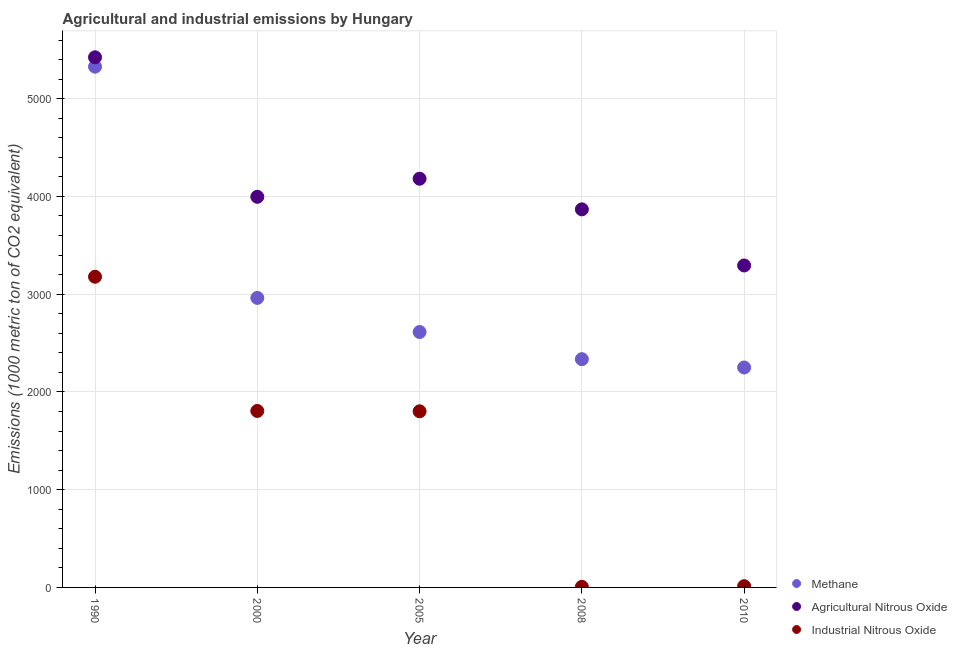How many different coloured dotlines are there?
Give a very brief answer. 3. Is the number of dotlines equal to the number of legend labels?
Offer a terse response. Yes. What is the amount of industrial nitrous oxide emissions in 2010?
Make the answer very short. 12.5. Across all years, what is the maximum amount of methane emissions?
Provide a short and direct response. 5327.6. Across all years, what is the minimum amount of methane emissions?
Your answer should be compact. 2250. In which year was the amount of methane emissions maximum?
Provide a short and direct response. 1990. What is the total amount of agricultural nitrous oxide emissions in the graph?
Keep it short and to the point. 2.08e+04. What is the difference between the amount of methane emissions in 2008 and that in 2010?
Make the answer very short. 85.2. What is the difference between the amount of industrial nitrous oxide emissions in 2010 and the amount of methane emissions in 2008?
Offer a very short reply. -2322.7. What is the average amount of agricultural nitrous oxide emissions per year?
Your response must be concise. 4152.54. In the year 1990, what is the difference between the amount of agricultural nitrous oxide emissions and amount of methane emissions?
Your answer should be compact. 95.9. What is the ratio of the amount of agricultural nitrous oxide emissions in 2000 to that in 2010?
Your answer should be compact. 1.21. What is the difference between the highest and the second highest amount of industrial nitrous oxide emissions?
Give a very brief answer. 1373.2. What is the difference between the highest and the lowest amount of industrial nitrous oxide emissions?
Provide a short and direct response. 3172.6. In how many years, is the amount of industrial nitrous oxide emissions greater than the average amount of industrial nitrous oxide emissions taken over all years?
Make the answer very short. 3. Is it the case that in every year, the sum of the amount of methane emissions and amount of agricultural nitrous oxide emissions is greater than the amount of industrial nitrous oxide emissions?
Your answer should be compact. Yes. What is the difference between two consecutive major ticks on the Y-axis?
Make the answer very short. 1000. Does the graph contain any zero values?
Keep it short and to the point. No. Where does the legend appear in the graph?
Give a very brief answer. Bottom right. How many legend labels are there?
Offer a very short reply. 3. How are the legend labels stacked?
Ensure brevity in your answer.  Vertical. What is the title of the graph?
Provide a short and direct response. Agricultural and industrial emissions by Hungary. Does "Agricultural Nitrous Oxide" appear as one of the legend labels in the graph?
Your answer should be very brief. Yes. What is the label or title of the X-axis?
Your answer should be compact. Year. What is the label or title of the Y-axis?
Your answer should be very brief. Emissions (1000 metric ton of CO2 equivalent). What is the Emissions (1000 metric ton of CO2 equivalent) in Methane in 1990?
Your answer should be very brief. 5327.6. What is the Emissions (1000 metric ton of CO2 equivalent) of Agricultural Nitrous Oxide in 1990?
Your response must be concise. 5423.5. What is the Emissions (1000 metric ton of CO2 equivalent) of Industrial Nitrous Oxide in 1990?
Offer a terse response. 3178.6. What is the Emissions (1000 metric ton of CO2 equivalent) in Methane in 2000?
Provide a short and direct response. 2961.9. What is the Emissions (1000 metric ton of CO2 equivalent) of Agricultural Nitrous Oxide in 2000?
Your response must be concise. 3996.3. What is the Emissions (1000 metric ton of CO2 equivalent) in Industrial Nitrous Oxide in 2000?
Provide a succinct answer. 1805.4. What is the Emissions (1000 metric ton of CO2 equivalent) in Methane in 2005?
Your response must be concise. 2613. What is the Emissions (1000 metric ton of CO2 equivalent) in Agricultural Nitrous Oxide in 2005?
Make the answer very short. 4181.2. What is the Emissions (1000 metric ton of CO2 equivalent) in Industrial Nitrous Oxide in 2005?
Provide a short and direct response. 1802. What is the Emissions (1000 metric ton of CO2 equivalent) in Methane in 2008?
Provide a succinct answer. 2335.2. What is the Emissions (1000 metric ton of CO2 equivalent) of Agricultural Nitrous Oxide in 2008?
Provide a short and direct response. 3868. What is the Emissions (1000 metric ton of CO2 equivalent) of Methane in 2010?
Provide a succinct answer. 2250. What is the Emissions (1000 metric ton of CO2 equivalent) of Agricultural Nitrous Oxide in 2010?
Provide a short and direct response. 3293.7. Across all years, what is the maximum Emissions (1000 metric ton of CO2 equivalent) in Methane?
Make the answer very short. 5327.6. Across all years, what is the maximum Emissions (1000 metric ton of CO2 equivalent) of Agricultural Nitrous Oxide?
Provide a short and direct response. 5423.5. Across all years, what is the maximum Emissions (1000 metric ton of CO2 equivalent) in Industrial Nitrous Oxide?
Provide a short and direct response. 3178.6. Across all years, what is the minimum Emissions (1000 metric ton of CO2 equivalent) of Methane?
Your answer should be very brief. 2250. Across all years, what is the minimum Emissions (1000 metric ton of CO2 equivalent) of Agricultural Nitrous Oxide?
Ensure brevity in your answer.  3293.7. What is the total Emissions (1000 metric ton of CO2 equivalent) in Methane in the graph?
Ensure brevity in your answer.  1.55e+04. What is the total Emissions (1000 metric ton of CO2 equivalent) in Agricultural Nitrous Oxide in the graph?
Provide a short and direct response. 2.08e+04. What is the total Emissions (1000 metric ton of CO2 equivalent) of Industrial Nitrous Oxide in the graph?
Provide a succinct answer. 6804.5. What is the difference between the Emissions (1000 metric ton of CO2 equivalent) of Methane in 1990 and that in 2000?
Provide a succinct answer. 2365.7. What is the difference between the Emissions (1000 metric ton of CO2 equivalent) of Agricultural Nitrous Oxide in 1990 and that in 2000?
Offer a terse response. 1427.2. What is the difference between the Emissions (1000 metric ton of CO2 equivalent) of Industrial Nitrous Oxide in 1990 and that in 2000?
Offer a terse response. 1373.2. What is the difference between the Emissions (1000 metric ton of CO2 equivalent) in Methane in 1990 and that in 2005?
Offer a terse response. 2714.6. What is the difference between the Emissions (1000 metric ton of CO2 equivalent) of Agricultural Nitrous Oxide in 1990 and that in 2005?
Your response must be concise. 1242.3. What is the difference between the Emissions (1000 metric ton of CO2 equivalent) of Industrial Nitrous Oxide in 1990 and that in 2005?
Your answer should be compact. 1376.6. What is the difference between the Emissions (1000 metric ton of CO2 equivalent) of Methane in 1990 and that in 2008?
Offer a very short reply. 2992.4. What is the difference between the Emissions (1000 metric ton of CO2 equivalent) of Agricultural Nitrous Oxide in 1990 and that in 2008?
Provide a short and direct response. 1555.5. What is the difference between the Emissions (1000 metric ton of CO2 equivalent) of Industrial Nitrous Oxide in 1990 and that in 2008?
Provide a succinct answer. 3172.6. What is the difference between the Emissions (1000 metric ton of CO2 equivalent) in Methane in 1990 and that in 2010?
Provide a short and direct response. 3077.6. What is the difference between the Emissions (1000 metric ton of CO2 equivalent) in Agricultural Nitrous Oxide in 1990 and that in 2010?
Your answer should be compact. 2129.8. What is the difference between the Emissions (1000 metric ton of CO2 equivalent) of Industrial Nitrous Oxide in 1990 and that in 2010?
Your response must be concise. 3166.1. What is the difference between the Emissions (1000 metric ton of CO2 equivalent) in Methane in 2000 and that in 2005?
Make the answer very short. 348.9. What is the difference between the Emissions (1000 metric ton of CO2 equivalent) in Agricultural Nitrous Oxide in 2000 and that in 2005?
Provide a succinct answer. -184.9. What is the difference between the Emissions (1000 metric ton of CO2 equivalent) of Methane in 2000 and that in 2008?
Your answer should be very brief. 626.7. What is the difference between the Emissions (1000 metric ton of CO2 equivalent) of Agricultural Nitrous Oxide in 2000 and that in 2008?
Your answer should be compact. 128.3. What is the difference between the Emissions (1000 metric ton of CO2 equivalent) of Industrial Nitrous Oxide in 2000 and that in 2008?
Offer a terse response. 1799.4. What is the difference between the Emissions (1000 metric ton of CO2 equivalent) in Methane in 2000 and that in 2010?
Make the answer very short. 711.9. What is the difference between the Emissions (1000 metric ton of CO2 equivalent) in Agricultural Nitrous Oxide in 2000 and that in 2010?
Offer a very short reply. 702.6. What is the difference between the Emissions (1000 metric ton of CO2 equivalent) in Industrial Nitrous Oxide in 2000 and that in 2010?
Provide a succinct answer. 1792.9. What is the difference between the Emissions (1000 metric ton of CO2 equivalent) in Methane in 2005 and that in 2008?
Offer a very short reply. 277.8. What is the difference between the Emissions (1000 metric ton of CO2 equivalent) of Agricultural Nitrous Oxide in 2005 and that in 2008?
Make the answer very short. 313.2. What is the difference between the Emissions (1000 metric ton of CO2 equivalent) of Industrial Nitrous Oxide in 2005 and that in 2008?
Offer a very short reply. 1796. What is the difference between the Emissions (1000 metric ton of CO2 equivalent) of Methane in 2005 and that in 2010?
Make the answer very short. 363. What is the difference between the Emissions (1000 metric ton of CO2 equivalent) of Agricultural Nitrous Oxide in 2005 and that in 2010?
Your answer should be compact. 887.5. What is the difference between the Emissions (1000 metric ton of CO2 equivalent) in Industrial Nitrous Oxide in 2005 and that in 2010?
Keep it short and to the point. 1789.5. What is the difference between the Emissions (1000 metric ton of CO2 equivalent) of Methane in 2008 and that in 2010?
Provide a short and direct response. 85.2. What is the difference between the Emissions (1000 metric ton of CO2 equivalent) of Agricultural Nitrous Oxide in 2008 and that in 2010?
Your response must be concise. 574.3. What is the difference between the Emissions (1000 metric ton of CO2 equivalent) in Methane in 1990 and the Emissions (1000 metric ton of CO2 equivalent) in Agricultural Nitrous Oxide in 2000?
Your answer should be compact. 1331.3. What is the difference between the Emissions (1000 metric ton of CO2 equivalent) of Methane in 1990 and the Emissions (1000 metric ton of CO2 equivalent) of Industrial Nitrous Oxide in 2000?
Offer a very short reply. 3522.2. What is the difference between the Emissions (1000 metric ton of CO2 equivalent) of Agricultural Nitrous Oxide in 1990 and the Emissions (1000 metric ton of CO2 equivalent) of Industrial Nitrous Oxide in 2000?
Provide a short and direct response. 3618.1. What is the difference between the Emissions (1000 metric ton of CO2 equivalent) in Methane in 1990 and the Emissions (1000 metric ton of CO2 equivalent) in Agricultural Nitrous Oxide in 2005?
Your answer should be very brief. 1146.4. What is the difference between the Emissions (1000 metric ton of CO2 equivalent) in Methane in 1990 and the Emissions (1000 metric ton of CO2 equivalent) in Industrial Nitrous Oxide in 2005?
Your answer should be very brief. 3525.6. What is the difference between the Emissions (1000 metric ton of CO2 equivalent) of Agricultural Nitrous Oxide in 1990 and the Emissions (1000 metric ton of CO2 equivalent) of Industrial Nitrous Oxide in 2005?
Your answer should be compact. 3621.5. What is the difference between the Emissions (1000 metric ton of CO2 equivalent) in Methane in 1990 and the Emissions (1000 metric ton of CO2 equivalent) in Agricultural Nitrous Oxide in 2008?
Offer a very short reply. 1459.6. What is the difference between the Emissions (1000 metric ton of CO2 equivalent) of Methane in 1990 and the Emissions (1000 metric ton of CO2 equivalent) of Industrial Nitrous Oxide in 2008?
Give a very brief answer. 5321.6. What is the difference between the Emissions (1000 metric ton of CO2 equivalent) of Agricultural Nitrous Oxide in 1990 and the Emissions (1000 metric ton of CO2 equivalent) of Industrial Nitrous Oxide in 2008?
Offer a very short reply. 5417.5. What is the difference between the Emissions (1000 metric ton of CO2 equivalent) in Methane in 1990 and the Emissions (1000 metric ton of CO2 equivalent) in Agricultural Nitrous Oxide in 2010?
Ensure brevity in your answer.  2033.9. What is the difference between the Emissions (1000 metric ton of CO2 equivalent) of Methane in 1990 and the Emissions (1000 metric ton of CO2 equivalent) of Industrial Nitrous Oxide in 2010?
Provide a succinct answer. 5315.1. What is the difference between the Emissions (1000 metric ton of CO2 equivalent) of Agricultural Nitrous Oxide in 1990 and the Emissions (1000 metric ton of CO2 equivalent) of Industrial Nitrous Oxide in 2010?
Keep it short and to the point. 5411. What is the difference between the Emissions (1000 metric ton of CO2 equivalent) of Methane in 2000 and the Emissions (1000 metric ton of CO2 equivalent) of Agricultural Nitrous Oxide in 2005?
Give a very brief answer. -1219.3. What is the difference between the Emissions (1000 metric ton of CO2 equivalent) in Methane in 2000 and the Emissions (1000 metric ton of CO2 equivalent) in Industrial Nitrous Oxide in 2005?
Ensure brevity in your answer.  1159.9. What is the difference between the Emissions (1000 metric ton of CO2 equivalent) in Agricultural Nitrous Oxide in 2000 and the Emissions (1000 metric ton of CO2 equivalent) in Industrial Nitrous Oxide in 2005?
Give a very brief answer. 2194.3. What is the difference between the Emissions (1000 metric ton of CO2 equivalent) in Methane in 2000 and the Emissions (1000 metric ton of CO2 equivalent) in Agricultural Nitrous Oxide in 2008?
Provide a succinct answer. -906.1. What is the difference between the Emissions (1000 metric ton of CO2 equivalent) of Methane in 2000 and the Emissions (1000 metric ton of CO2 equivalent) of Industrial Nitrous Oxide in 2008?
Your answer should be compact. 2955.9. What is the difference between the Emissions (1000 metric ton of CO2 equivalent) of Agricultural Nitrous Oxide in 2000 and the Emissions (1000 metric ton of CO2 equivalent) of Industrial Nitrous Oxide in 2008?
Ensure brevity in your answer.  3990.3. What is the difference between the Emissions (1000 metric ton of CO2 equivalent) of Methane in 2000 and the Emissions (1000 metric ton of CO2 equivalent) of Agricultural Nitrous Oxide in 2010?
Keep it short and to the point. -331.8. What is the difference between the Emissions (1000 metric ton of CO2 equivalent) of Methane in 2000 and the Emissions (1000 metric ton of CO2 equivalent) of Industrial Nitrous Oxide in 2010?
Offer a terse response. 2949.4. What is the difference between the Emissions (1000 metric ton of CO2 equivalent) of Agricultural Nitrous Oxide in 2000 and the Emissions (1000 metric ton of CO2 equivalent) of Industrial Nitrous Oxide in 2010?
Your answer should be very brief. 3983.8. What is the difference between the Emissions (1000 metric ton of CO2 equivalent) in Methane in 2005 and the Emissions (1000 metric ton of CO2 equivalent) in Agricultural Nitrous Oxide in 2008?
Your answer should be compact. -1255. What is the difference between the Emissions (1000 metric ton of CO2 equivalent) in Methane in 2005 and the Emissions (1000 metric ton of CO2 equivalent) in Industrial Nitrous Oxide in 2008?
Your answer should be very brief. 2607. What is the difference between the Emissions (1000 metric ton of CO2 equivalent) in Agricultural Nitrous Oxide in 2005 and the Emissions (1000 metric ton of CO2 equivalent) in Industrial Nitrous Oxide in 2008?
Offer a very short reply. 4175.2. What is the difference between the Emissions (1000 metric ton of CO2 equivalent) of Methane in 2005 and the Emissions (1000 metric ton of CO2 equivalent) of Agricultural Nitrous Oxide in 2010?
Offer a very short reply. -680.7. What is the difference between the Emissions (1000 metric ton of CO2 equivalent) in Methane in 2005 and the Emissions (1000 metric ton of CO2 equivalent) in Industrial Nitrous Oxide in 2010?
Your answer should be very brief. 2600.5. What is the difference between the Emissions (1000 metric ton of CO2 equivalent) of Agricultural Nitrous Oxide in 2005 and the Emissions (1000 metric ton of CO2 equivalent) of Industrial Nitrous Oxide in 2010?
Your response must be concise. 4168.7. What is the difference between the Emissions (1000 metric ton of CO2 equivalent) in Methane in 2008 and the Emissions (1000 metric ton of CO2 equivalent) in Agricultural Nitrous Oxide in 2010?
Your response must be concise. -958.5. What is the difference between the Emissions (1000 metric ton of CO2 equivalent) of Methane in 2008 and the Emissions (1000 metric ton of CO2 equivalent) of Industrial Nitrous Oxide in 2010?
Offer a terse response. 2322.7. What is the difference between the Emissions (1000 metric ton of CO2 equivalent) in Agricultural Nitrous Oxide in 2008 and the Emissions (1000 metric ton of CO2 equivalent) in Industrial Nitrous Oxide in 2010?
Give a very brief answer. 3855.5. What is the average Emissions (1000 metric ton of CO2 equivalent) of Methane per year?
Provide a short and direct response. 3097.54. What is the average Emissions (1000 metric ton of CO2 equivalent) of Agricultural Nitrous Oxide per year?
Offer a terse response. 4152.54. What is the average Emissions (1000 metric ton of CO2 equivalent) of Industrial Nitrous Oxide per year?
Your answer should be very brief. 1360.9. In the year 1990, what is the difference between the Emissions (1000 metric ton of CO2 equivalent) of Methane and Emissions (1000 metric ton of CO2 equivalent) of Agricultural Nitrous Oxide?
Provide a succinct answer. -95.9. In the year 1990, what is the difference between the Emissions (1000 metric ton of CO2 equivalent) of Methane and Emissions (1000 metric ton of CO2 equivalent) of Industrial Nitrous Oxide?
Your answer should be very brief. 2149. In the year 1990, what is the difference between the Emissions (1000 metric ton of CO2 equivalent) of Agricultural Nitrous Oxide and Emissions (1000 metric ton of CO2 equivalent) of Industrial Nitrous Oxide?
Keep it short and to the point. 2244.9. In the year 2000, what is the difference between the Emissions (1000 metric ton of CO2 equivalent) of Methane and Emissions (1000 metric ton of CO2 equivalent) of Agricultural Nitrous Oxide?
Offer a very short reply. -1034.4. In the year 2000, what is the difference between the Emissions (1000 metric ton of CO2 equivalent) in Methane and Emissions (1000 metric ton of CO2 equivalent) in Industrial Nitrous Oxide?
Your answer should be very brief. 1156.5. In the year 2000, what is the difference between the Emissions (1000 metric ton of CO2 equivalent) in Agricultural Nitrous Oxide and Emissions (1000 metric ton of CO2 equivalent) in Industrial Nitrous Oxide?
Make the answer very short. 2190.9. In the year 2005, what is the difference between the Emissions (1000 metric ton of CO2 equivalent) of Methane and Emissions (1000 metric ton of CO2 equivalent) of Agricultural Nitrous Oxide?
Offer a very short reply. -1568.2. In the year 2005, what is the difference between the Emissions (1000 metric ton of CO2 equivalent) in Methane and Emissions (1000 metric ton of CO2 equivalent) in Industrial Nitrous Oxide?
Your answer should be very brief. 811. In the year 2005, what is the difference between the Emissions (1000 metric ton of CO2 equivalent) in Agricultural Nitrous Oxide and Emissions (1000 metric ton of CO2 equivalent) in Industrial Nitrous Oxide?
Offer a terse response. 2379.2. In the year 2008, what is the difference between the Emissions (1000 metric ton of CO2 equivalent) of Methane and Emissions (1000 metric ton of CO2 equivalent) of Agricultural Nitrous Oxide?
Keep it short and to the point. -1532.8. In the year 2008, what is the difference between the Emissions (1000 metric ton of CO2 equivalent) of Methane and Emissions (1000 metric ton of CO2 equivalent) of Industrial Nitrous Oxide?
Offer a terse response. 2329.2. In the year 2008, what is the difference between the Emissions (1000 metric ton of CO2 equivalent) in Agricultural Nitrous Oxide and Emissions (1000 metric ton of CO2 equivalent) in Industrial Nitrous Oxide?
Make the answer very short. 3862. In the year 2010, what is the difference between the Emissions (1000 metric ton of CO2 equivalent) in Methane and Emissions (1000 metric ton of CO2 equivalent) in Agricultural Nitrous Oxide?
Give a very brief answer. -1043.7. In the year 2010, what is the difference between the Emissions (1000 metric ton of CO2 equivalent) in Methane and Emissions (1000 metric ton of CO2 equivalent) in Industrial Nitrous Oxide?
Offer a terse response. 2237.5. In the year 2010, what is the difference between the Emissions (1000 metric ton of CO2 equivalent) of Agricultural Nitrous Oxide and Emissions (1000 metric ton of CO2 equivalent) of Industrial Nitrous Oxide?
Keep it short and to the point. 3281.2. What is the ratio of the Emissions (1000 metric ton of CO2 equivalent) in Methane in 1990 to that in 2000?
Offer a very short reply. 1.8. What is the ratio of the Emissions (1000 metric ton of CO2 equivalent) in Agricultural Nitrous Oxide in 1990 to that in 2000?
Ensure brevity in your answer.  1.36. What is the ratio of the Emissions (1000 metric ton of CO2 equivalent) of Industrial Nitrous Oxide in 1990 to that in 2000?
Your answer should be compact. 1.76. What is the ratio of the Emissions (1000 metric ton of CO2 equivalent) in Methane in 1990 to that in 2005?
Keep it short and to the point. 2.04. What is the ratio of the Emissions (1000 metric ton of CO2 equivalent) of Agricultural Nitrous Oxide in 1990 to that in 2005?
Your answer should be compact. 1.3. What is the ratio of the Emissions (1000 metric ton of CO2 equivalent) in Industrial Nitrous Oxide in 1990 to that in 2005?
Your response must be concise. 1.76. What is the ratio of the Emissions (1000 metric ton of CO2 equivalent) in Methane in 1990 to that in 2008?
Provide a short and direct response. 2.28. What is the ratio of the Emissions (1000 metric ton of CO2 equivalent) of Agricultural Nitrous Oxide in 1990 to that in 2008?
Your answer should be very brief. 1.4. What is the ratio of the Emissions (1000 metric ton of CO2 equivalent) in Industrial Nitrous Oxide in 1990 to that in 2008?
Give a very brief answer. 529.77. What is the ratio of the Emissions (1000 metric ton of CO2 equivalent) of Methane in 1990 to that in 2010?
Give a very brief answer. 2.37. What is the ratio of the Emissions (1000 metric ton of CO2 equivalent) in Agricultural Nitrous Oxide in 1990 to that in 2010?
Give a very brief answer. 1.65. What is the ratio of the Emissions (1000 metric ton of CO2 equivalent) of Industrial Nitrous Oxide in 1990 to that in 2010?
Provide a succinct answer. 254.29. What is the ratio of the Emissions (1000 metric ton of CO2 equivalent) in Methane in 2000 to that in 2005?
Provide a short and direct response. 1.13. What is the ratio of the Emissions (1000 metric ton of CO2 equivalent) in Agricultural Nitrous Oxide in 2000 to that in 2005?
Your answer should be very brief. 0.96. What is the ratio of the Emissions (1000 metric ton of CO2 equivalent) in Industrial Nitrous Oxide in 2000 to that in 2005?
Give a very brief answer. 1. What is the ratio of the Emissions (1000 metric ton of CO2 equivalent) of Methane in 2000 to that in 2008?
Ensure brevity in your answer.  1.27. What is the ratio of the Emissions (1000 metric ton of CO2 equivalent) of Agricultural Nitrous Oxide in 2000 to that in 2008?
Make the answer very short. 1.03. What is the ratio of the Emissions (1000 metric ton of CO2 equivalent) of Industrial Nitrous Oxide in 2000 to that in 2008?
Provide a succinct answer. 300.9. What is the ratio of the Emissions (1000 metric ton of CO2 equivalent) in Methane in 2000 to that in 2010?
Provide a succinct answer. 1.32. What is the ratio of the Emissions (1000 metric ton of CO2 equivalent) of Agricultural Nitrous Oxide in 2000 to that in 2010?
Give a very brief answer. 1.21. What is the ratio of the Emissions (1000 metric ton of CO2 equivalent) of Industrial Nitrous Oxide in 2000 to that in 2010?
Provide a succinct answer. 144.43. What is the ratio of the Emissions (1000 metric ton of CO2 equivalent) in Methane in 2005 to that in 2008?
Make the answer very short. 1.12. What is the ratio of the Emissions (1000 metric ton of CO2 equivalent) of Agricultural Nitrous Oxide in 2005 to that in 2008?
Give a very brief answer. 1.08. What is the ratio of the Emissions (1000 metric ton of CO2 equivalent) in Industrial Nitrous Oxide in 2005 to that in 2008?
Offer a terse response. 300.33. What is the ratio of the Emissions (1000 metric ton of CO2 equivalent) of Methane in 2005 to that in 2010?
Ensure brevity in your answer.  1.16. What is the ratio of the Emissions (1000 metric ton of CO2 equivalent) of Agricultural Nitrous Oxide in 2005 to that in 2010?
Give a very brief answer. 1.27. What is the ratio of the Emissions (1000 metric ton of CO2 equivalent) in Industrial Nitrous Oxide in 2005 to that in 2010?
Keep it short and to the point. 144.16. What is the ratio of the Emissions (1000 metric ton of CO2 equivalent) of Methane in 2008 to that in 2010?
Provide a succinct answer. 1.04. What is the ratio of the Emissions (1000 metric ton of CO2 equivalent) in Agricultural Nitrous Oxide in 2008 to that in 2010?
Ensure brevity in your answer.  1.17. What is the ratio of the Emissions (1000 metric ton of CO2 equivalent) of Industrial Nitrous Oxide in 2008 to that in 2010?
Your response must be concise. 0.48. What is the difference between the highest and the second highest Emissions (1000 metric ton of CO2 equivalent) of Methane?
Provide a succinct answer. 2365.7. What is the difference between the highest and the second highest Emissions (1000 metric ton of CO2 equivalent) in Agricultural Nitrous Oxide?
Keep it short and to the point. 1242.3. What is the difference between the highest and the second highest Emissions (1000 metric ton of CO2 equivalent) in Industrial Nitrous Oxide?
Your response must be concise. 1373.2. What is the difference between the highest and the lowest Emissions (1000 metric ton of CO2 equivalent) in Methane?
Offer a terse response. 3077.6. What is the difference between the highest and the lowest Emissions (1000 metric ton of CO2 equivalent) of Agricultural Nitrous Oxide?
Give a very brief answer. 2129.8. What is the difference between the highest and the lowest Emissions (1000 metric ton of CO2 equivalent) in Industrial Nitrous Oxide?
Make the answer very short. 3172.6. 